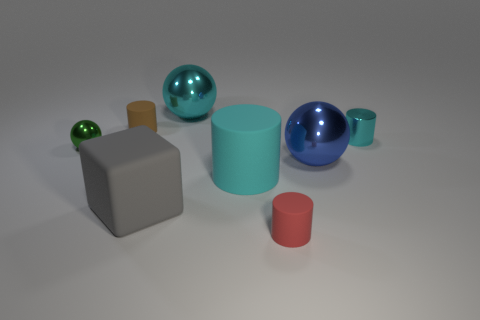Add 1 big cylinders. How many objects exist? 9 Subtract all tiny spheres. How many spheres are left? 2 Subtract 0 yellow cubes. How many objects are left? 8 Subtract all cubes. How many objects are left? 7 Subtract 3 cylinders. How many cylinders are left? 1 Subtract all purple spheres. Subtract all gray cubes. How many spheres are left? 3 Subtract all yellow blocks. How many green balls are left? 1 Subtract all big cyan spheres. Subtract all tiny cyan metal things. How many objects are left? 6 Add 7 large gray rubber cubes. How many large gray rubber cubes are left? 8 Add 6 tiny yellow rubber cylinders. How many tiny yellow rubber cylinders exist? 6 